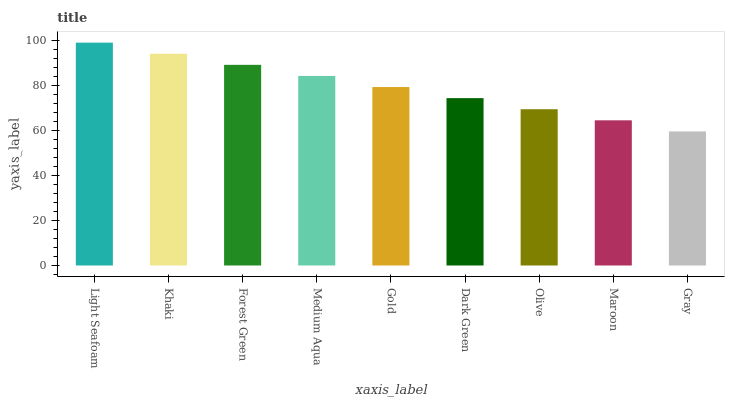Is Gray the minimum?
Answer yes or no. Yes. Is Light Seafoam the maximum?
Answer yes or no. Yes. Is Khaki the minimum?
Answer yes or no. No. Is Khaki the maximum?
Answer yes or no. No. Is Light Seafoam greater than Khaki?
Answer yes or no. Yes. Is Khaki less than Light Seafoam?
Answer yes or no. Yes. Is Khaki greater than Light Seafoam?
Answer yes or no. No. Is Light Seafoam less than Khaki?
Answer yes or no. No. Is Gold the high median?
Answer yes or no. Yes. Is Gold the low median?
Answer yes or no. Yes. Is Light Seafoam the high median?
Answer yes or no. No. Is Gray the low median?
Answer yes or no. No. 